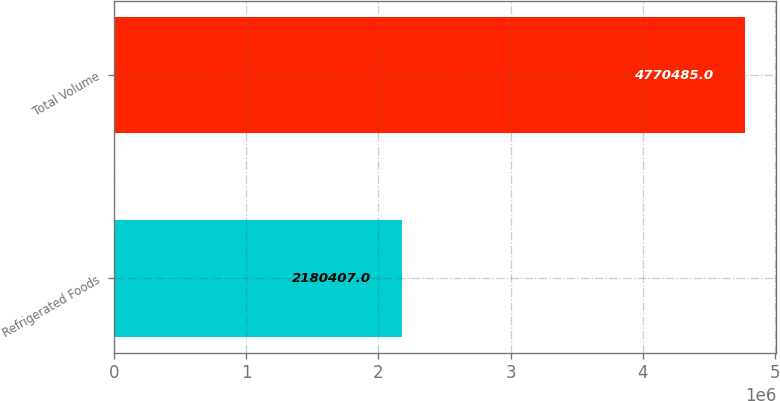Convert chart to OTSL. <chart><loc_0><loc_0><loc_500><loc_500><bar_chart><fcel>Refrigerated Foods<fcel>Total Volume<nl><fcel>2.18041e+06<fcel>4.77048e+06<nl></chart> 